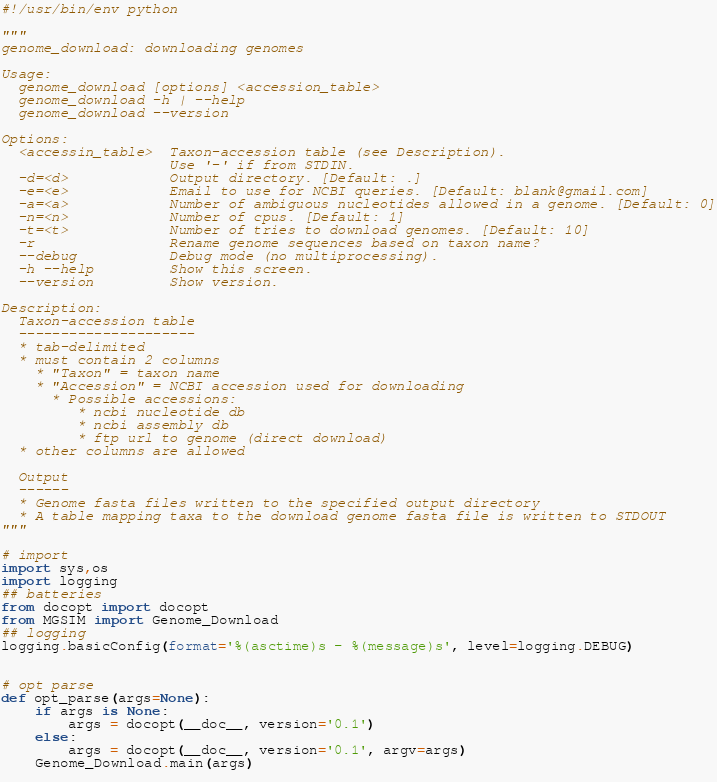Convert code to text. <code><loc_0><loc_0><loc_500><loc_500><_Python_>#!/usr/bin/env python

"""
genome_download: downloading genomes

Usage:
  genome_download [options] <accession_table>
  genome_download -h | --help
  genome_download --version

Options:
  <accessin_table>  Taxon-accession table (see Description).
                    Use '-' if from STDIN.
  -d=<d>            Output directory. [Default: .]
  -e=<e>            Email to use for NCBI queries. [Default: blank@gmail.com]
  -a=<a>            Number of ambiguous nucleotides allowed in a genome. [Default: 0]
  -n=<n>            Number of cpus. [Default: 1]
  -t=<t>            Number of tries to download genomes. [Default: 10]
  -r                Rename genome sequences based on taxon name?
  --debug           Debug mode (no multiprocessing).
  -h --help         Show this screen.
  --version         Show version.

Description:
  Taxon-accession table
  ---------------------
  * tab-delimited
  * must contain 2 columns
    * "Taxon" = taxon name
    * "Accession" = NCBI accession used for downloading 
      * Possible accessions:
         * ncbi nucleotide db
         * ncbi assembly db
         * ftp url to genome (direct download)
  * other columns are allowed

  Output
  ------
  * Genome fasta files written to the specified output directory
  * A table mapping taxa to the download genome fasta file is written to STDOUT
"""

# import
import sys,os
import logging
## batteries
from docopt import docopt
from MGSIM import Genome_Download
## logging
logging.basicConfig(format='%(asctime)s - %(message)s', level=logging.DEBUG)


# opt parse
def opt_parse(args=None):
    if args is None:        
        args = docopt(__doc__, version='0.1')
    else:
        args = docopt(__doc__, version='0.1', argv=args)
    Genome_Download.main(args)
   
</code> 